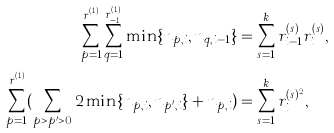Convert formula to latex. <formula><loc_0><loc_0><loc_500><loc_500>\sum _ { p = 1 } ^ { r ^ { ( 1 ) } _ { i } } \sum _ { q = 1 } ^ { r ^ { ( 1 ) } _ { i - 1 } } \min \{ n _ { p , i } , n _ { q , { i - 1 } } \} & = \sum _ { s = 1 } ^ { k } r ^ { ( s ) } _ { i - 1 } r _ { i } ^ { ( s ) } , & \\ \sum _ { p = 1 } ^ { r _ { i } ^ { ( 1 ) } } ( \sum _ { p > p ^ { \prime } > 0 } 2 \min \{ n _ { p , i } , n _ { p ^ { \prime } , i } \} + n _ { p , i } ) & = \sum _ { s = 1 } ^ { k } r ^ { ( s ) ^ { 2 } } _ { i } , &</formula> 